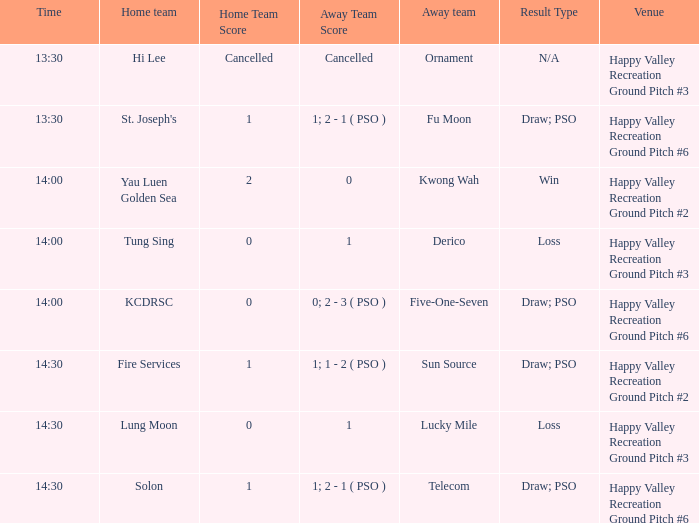Could you parse the entire table as a dict? {'header': ['Time', 'Home team', 'Home Team Score', 'Away Team Score', 'Away team', 'Result Type', 'Venue'], 'rows': [['13:30', 'Hi Lee', 'Cancelled', 'Cancelled', 'Ornament', 'N/A', 'Happy Valley Recreation Ground Pitch #3'], ['13:30', "St. Joseph's", '1', '1; 2 - 1 ( PSO )', 'Fu Moon', 'Draw; PSO', 'Happy Valley Recreation Ground Pitch #6'], ['14:00', 'Yau Luen Golden Sea', '2', '0', 'Kwong Wah', 'Win', 'Happy Valley Recreation Ground Pitch #2'], ['14:00', 'Tung Sing', '0', '1', 'Derico', 'Loss', 'Happy Valley Recreation Ground Pitch #3'], ['14:00', 'KCDRSC', '0', '0; 2 - 3 ( PSO )', 'Five-One-Seven', 'Draw; PSO', 'Happy Valley Recreation Ground Pitch #6'], ['14:30', 'Fire Services', '1', '1; 1 - 2 ( PSO )', 'Sun Source', 'Draw; PSO', 'Happy Valley Recreation Ground Pitch #2'], ['14:30', 'Lung Moon', '0', '1', 'Lucky Mile', 'Loss', 'Happy Valley Recreation Ground Pitch #3'], ['14:30', 'Solon', '1', '1; 2 - 1 ( PSO )', 'Telecom', 'Draw; PSO', 'Happy Valley Recreation Ground Pitch #6']]} What is the venue of the match with a 14:30 time and sun source as the away team? Happy Valley Recreation Ground Pitch #2. 